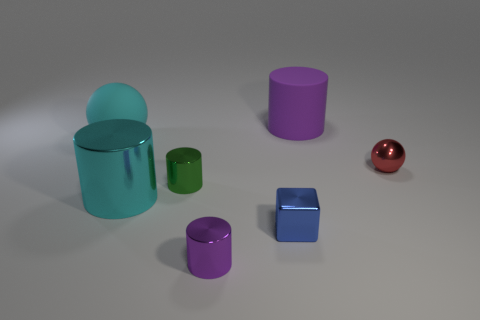There is a red object; what number of purple matte cylinders are behind it?
Offer a terse response. 1. Are there any purple matte things of the same shape as the tiny purple metal thing?
Provide a short and direct response. Yes. Is the shape of the big cyan shiny object the same as the large matte thing that is behind the cyan ball?
Offer a terse response. Yes. What number of balls are either big things or green metal objects?
Offer a terse response. 1. There is a large rubber thing that is to the left of the tiny green metallic object; what shape is it?
Offer a terse response. Sphere. How many other small cubes have the same material as the blue cube?
Offer a terse response. 0. Is the number of large cyan objects in front of the matte ball less than the number of tiny yellow shiny balls?
Provide a succinct answer. No. How big is the sphere in front of the cyan thing behind the tiny red shiny sphere?
Give a very brief answer. Small. There is a cube; is it the same color as the tiny metal object that is to the left of the small purple cylinder?
Offer a terse response. No. There is a green cylinder that is the same size as the purple metallic object; what material is it?
Give a very brief answer. Metal. 